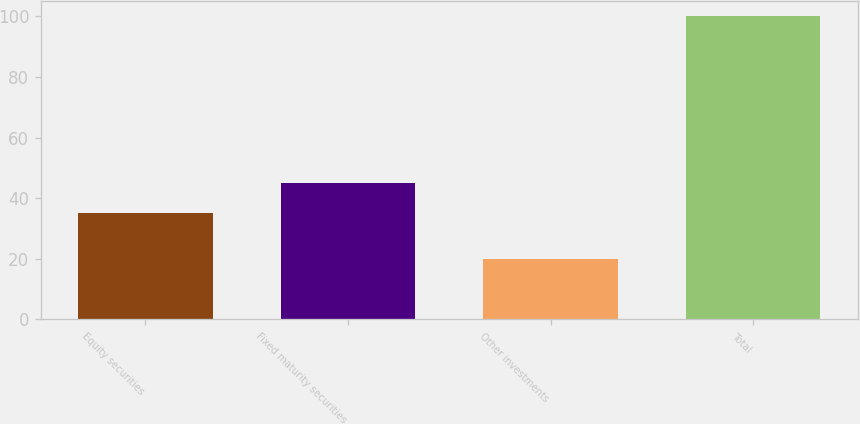<chart> <loc_0><loc_0><loc_500><loc_500><bar_chart><fcel>Equity securities<fcel>Fixed maturity securities<fcel>Other investments<fcel>Total<nl><fcel>35<fcel>45<fcel>20<fcel>100<nl></chart> 